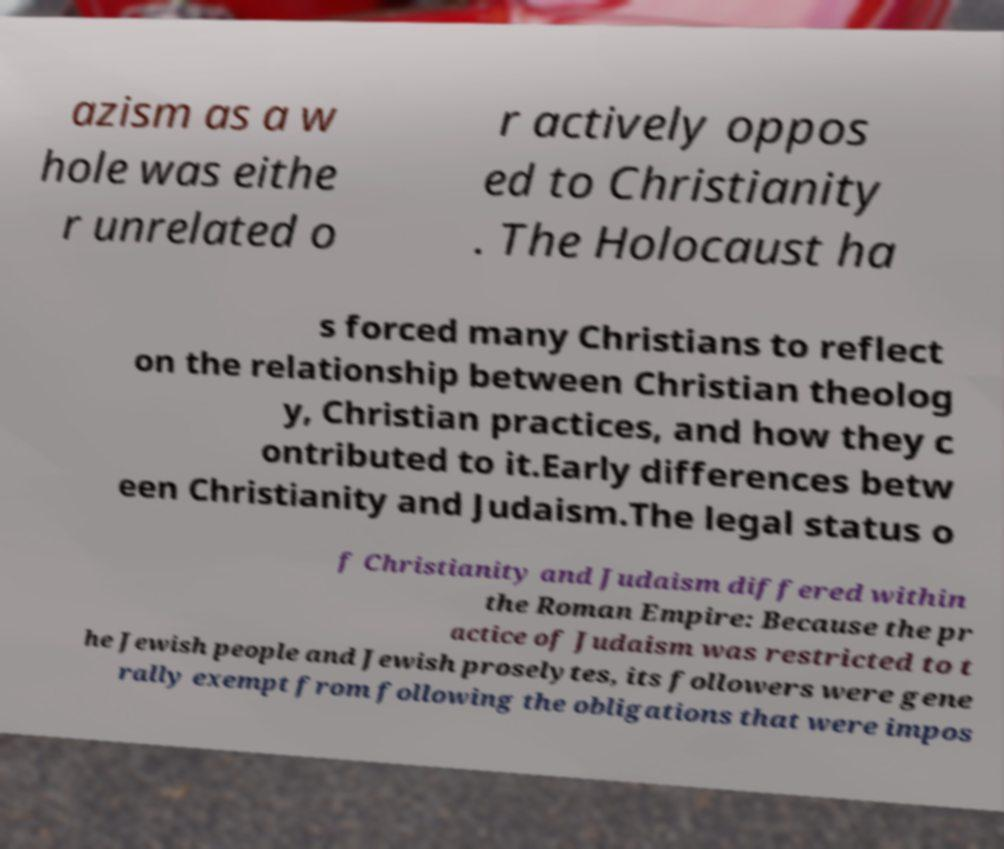For documentation purposes, I need the text within this image transcribed. Could you provide that? azism as a w hole was eithe r unrelated o r actively oppos ed to Christianity . The Holocaust ha s forced many Christians to reflect on the relationship between Christian theolog y, Christian practices, and how they c ontributed to it.Early differences betw een Christianity and Judaism.The legal status o f Christianity and Judaism differed within the Roman Empire: Because the pr actice of Judaism was restricted to t he Jewish people and Jewish proselytes, its followers were gene rally exempt from following the obligations that were impos 